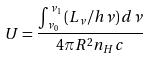Convert formula to latex. <formula><loc_0><loc_0><loc_500><loc_500>U = \frac { \int _ { \nu _ { 0 } } ^ { \nu _ { 1 } } \left ( L _ { \nu } / h \nu \right ) d \nu } { 4 \pi R ^ { 2 } n _ { H } c }</formula> 